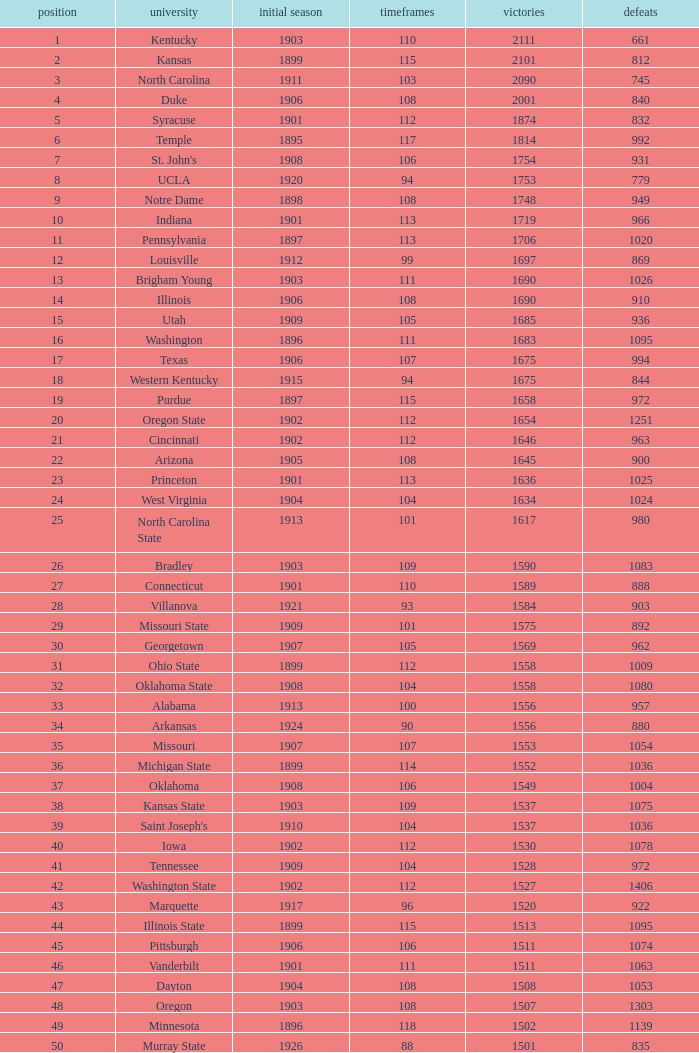How many wins were there for Washington State College with losses greater than 980 and a first season before 1906 and rank greater than 42? 0.0. 